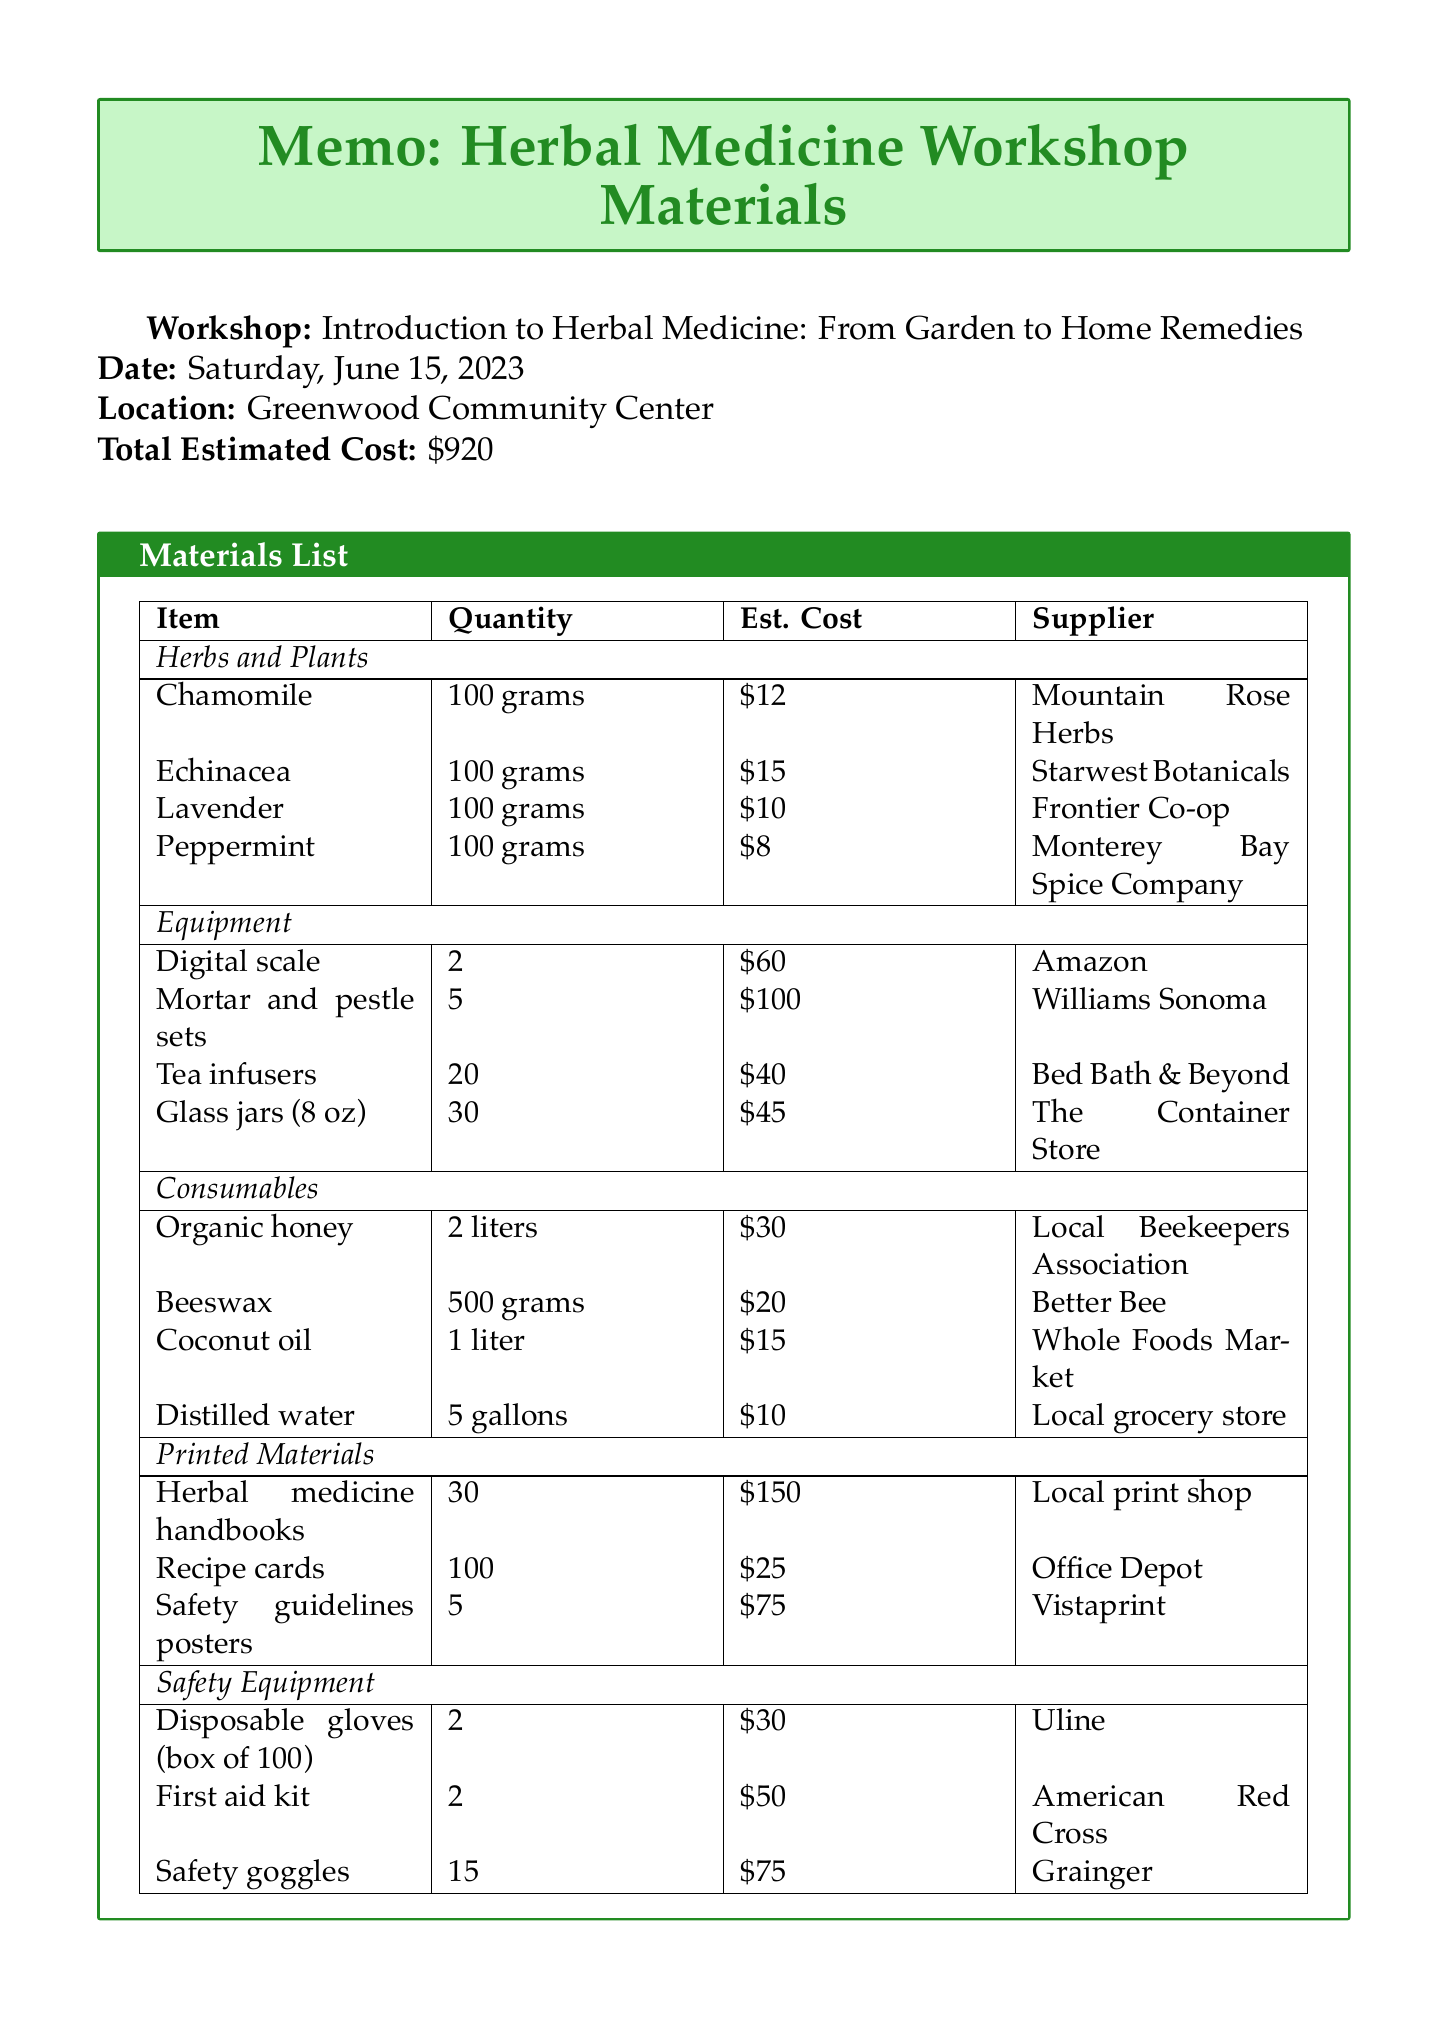What is the date of the workshop? The workshop is scheduled for Saturday, June 15, 2023.
Answer: Saturday, June 15, 2023 What is the total estimated cost for the workshop materials? The total estimated cost is stated at the end of the document as $920.
Answer: $920 How many herbs are listed in the materials list? There are four herbs listed in the "Herbs and Plants" section of the materials list.
Answer: 4 Who is responsible for confirming the availability of items? The document notes that the items should be confirmed with suppliers at least two weeks before the workshop, which implies it's the organizer's responsibility.
Answer: Organizer What type of safety equipment is included in the list? The safety equipment category includes items such as disposable gloves and first aid kits as mentioned in the document.
Answer: Disposable gloves, first aid kit, safety goggles How many digital scales are required for the workshop? The quantity of digital scales needed is specified to be two in the equipment section of the materials list.
Answer: 2 Where can the herbal medicine handbooks be sourced from? The herbal medicine handbooks are sourced from a local print shop.
Answer: Local print shop What should be included as a disclaimer for workshop participants? The document mentions including a disclaimer about potential allergies and consulting with a healthcare professional.
Answer: Allergies disclaimer What supplier provides peppermint? Peppermint is supplied by Monterey Bay Spice Company.
Answer: Monterey Bay Spice Company 